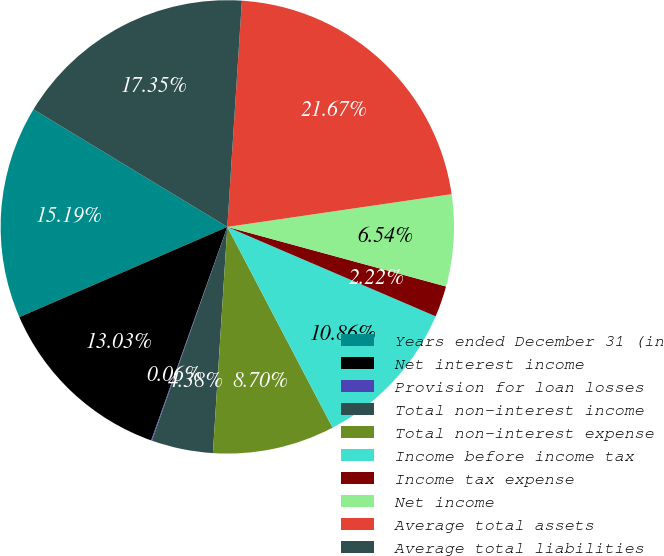Convert chart. <chart><loc_0><loc_0><loc_500><loc_500><pie_chart><fcel>Years ended December 31 (in<fcel>Net interest income<fcel>Provision for loan losses<fcel>Total non-interest income<fcel>Total non-interest expense<fcel>Income before income tax<fcel>Income tax expense<fcel>Net income<fcel>Average total assets<fcel>Average total liabilities<nl><fcel>15.19%<fcel>13.03%<fcel>0.06%<fcel>4.38%<fcel>8.7%<fcel>10.86%<fcel>2.22%<fcel>6.54%<fcel>21.67%<fcel>17.35%<nl></chart> 